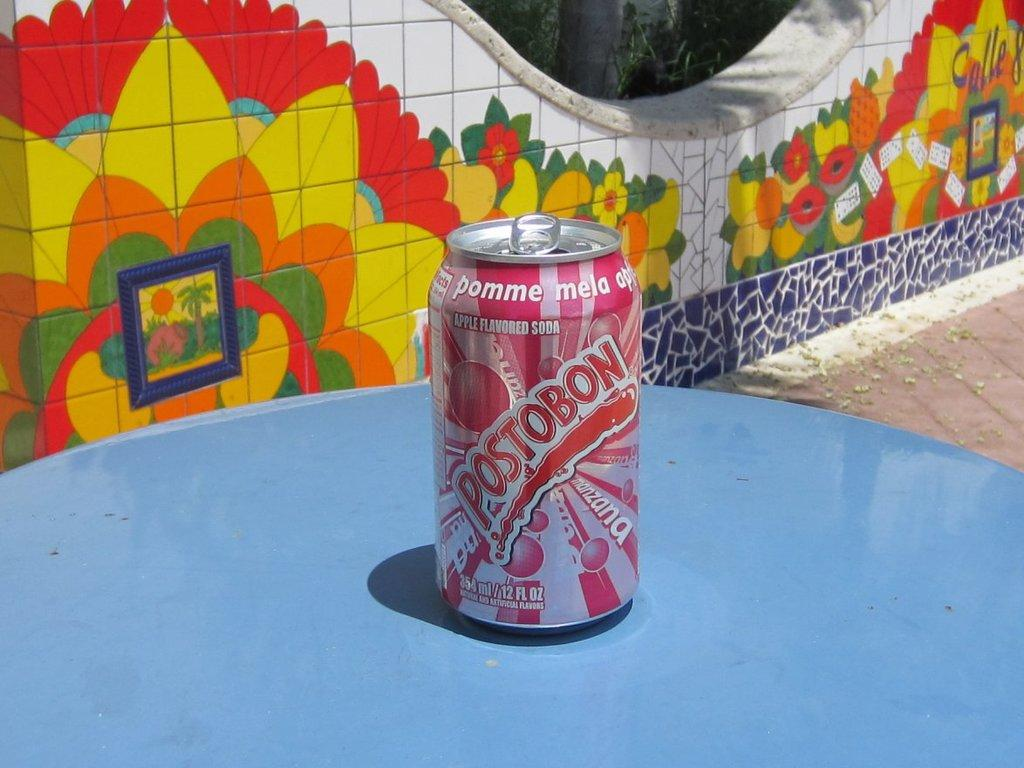<image>
Relay a brief, clear account of the picture shown. A can of Postobon soda sits on a blue table. 